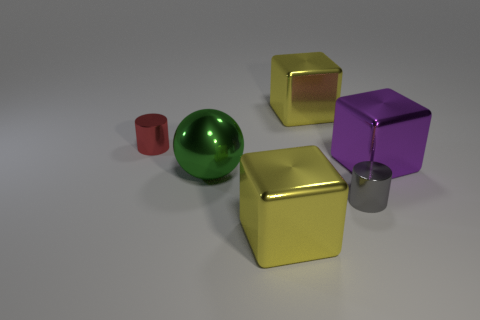What's the relative size of the purple object compared to the other objects? The purple cube is smaller than one of the yellow cubes but larger than the red cylinder and the gray cylinder. What geometric shape is the purple object? The purple object is a cube, which is a six-faced, three-dimensional shape with square faces and edges of equal length. 